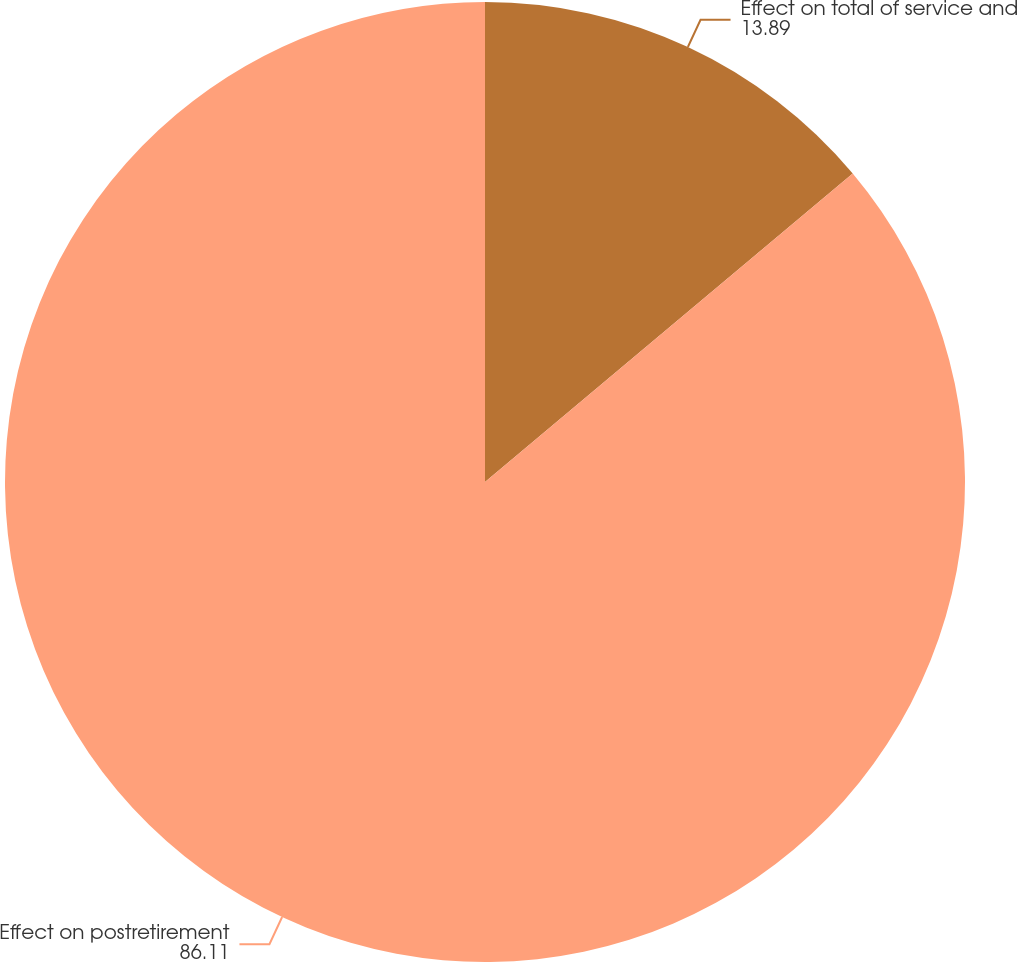Convert chart. <chart><loc_0><loc_0><loc_500><loc_500><pie_chart><fcel>Effect on total of service and<fcel>Effect on postretirement<nl><fcel>13.89%<fcel>86.11%<nl></chart> 